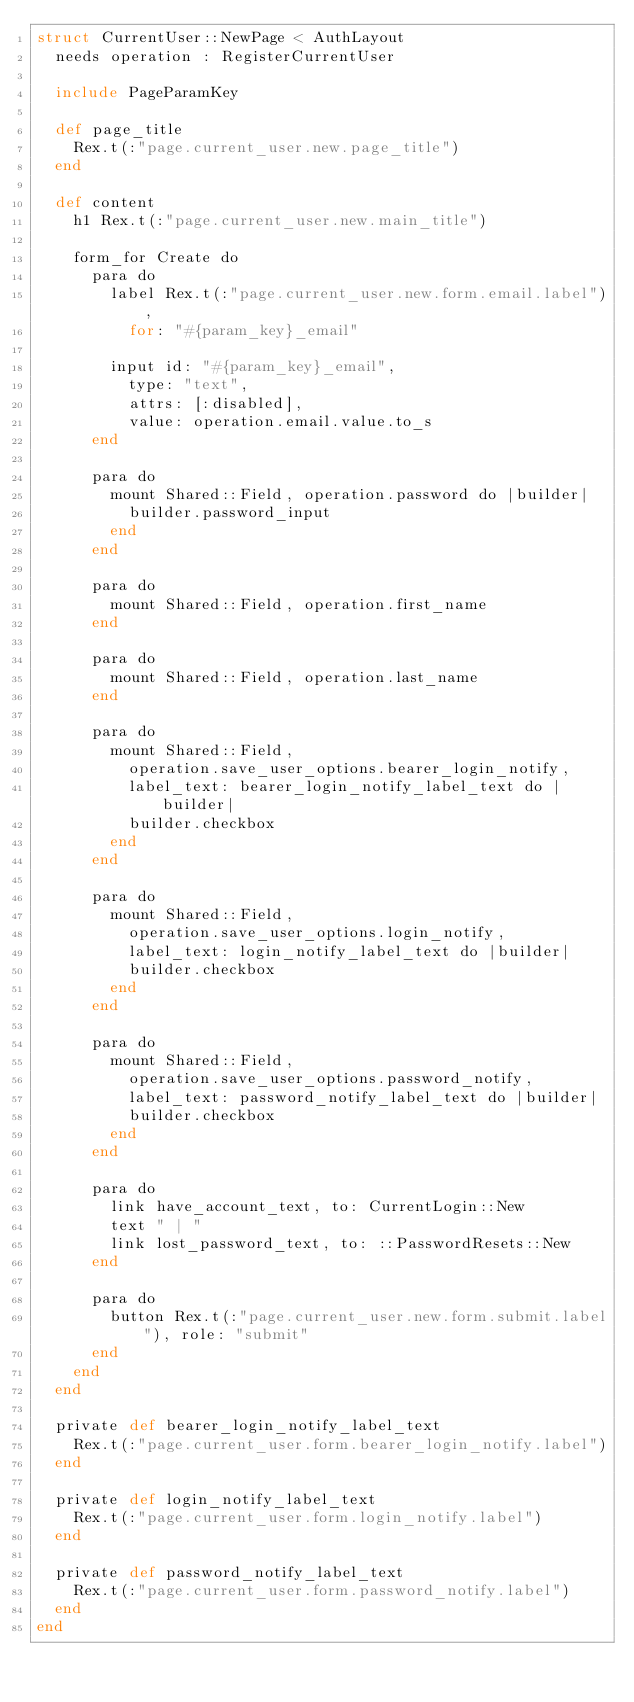<code> <loc_0><loc_0><loc_500><loc_500><_Crystal_>struct CurrentUser::NewPage < AuthLayout
  needs operation : RegisterCurrentUser

  include PageParamKey

  def page_title
    Rex.t(:"page.current_user.new.page_title")
  end

  def content
    h1 Rex.t(:"page.current_user.new.main_title")

    form_for Create do
      para do
        label Rex.t(:"page.current_user.new.form.email.label"),
          for: "#{param_key}_email"

        input id: "#{param_key}_email",
          type: "text",
          attrs: [:disabled],
          value: operation.email.value.to_s
      end

      para do
        mount Shared::Field, operation.password do |builder|
          builder.password_input
        end
      end

      para do
        mount Shared::Field, operation.first_name
      end

      para do
        mount Shared::Field, operation.last_name
      end

      para do
        mount Shared::Field,
          operation.save_user_options.bearer_login_notify,
          label_text: bearer_login_notify_label_text do |builder|
          builder.checkbox
        end
      end

      para do
        mount Shared::Field,
          operation.save_user_options.login_notify,
          label_text: login_notify_label_text do |builder|
          builder.checkbox
        end
      end

      para do
        mount Shared::Field,
          operation.save_user_options.password_notify,
          label_text: password_notify_label_text do |builder|
          builder.checkbox
        end
      end

      para do
        link have_account_text, to: CurrentLogin::New
        text " | "
        link lost_password_text, to: ::PasswordResets::New
      end

      para do
        button Rex.t(:"page.current_user.new.form.submit.label"), role: "submit"
      end
    end
  end

  private def bearer_login_notify_label_text
    Rex.t(:"page.current_user.form.bearer_login_notify.label")
  end

  private def login_notify_label_text
    Rex.t(:"page.current_user.form.login_notify.label")
  end

  private def password_notify_label_text
    Rex.t(:"page.current_user.form.password_notify.label")
  end
end
</code> 